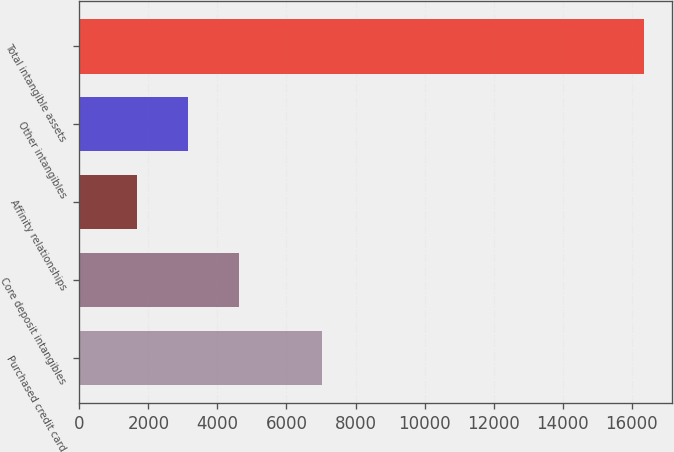Convert chart. <chart><loc_0><loc_0><loc_500><loc_500><bar_chart><fcel>Purchased credit card<fcel>Core deposit intangibles<fcel>Affinity relationships<fcel>Other intangibles<fcel>Total intangible assets<nl><fcel>7027<fcel>4615.2<fcel>1681<fcel>3148.1<fcel>16352<nl></chart> 